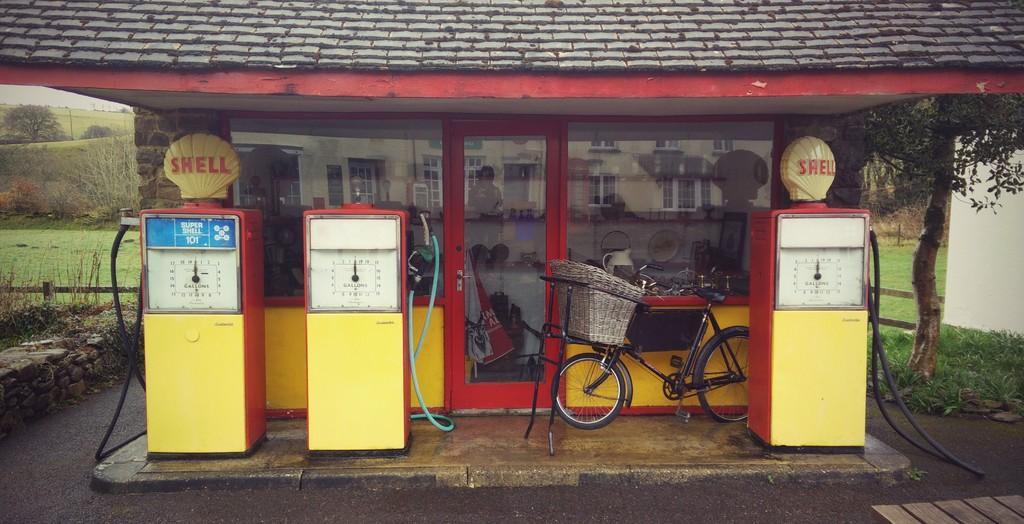Please provide a concise description of this image. In the picture we can see gas filling station, there is bicycle, glass door in which there is reflection of building and in the background of the picture there are some trees. 